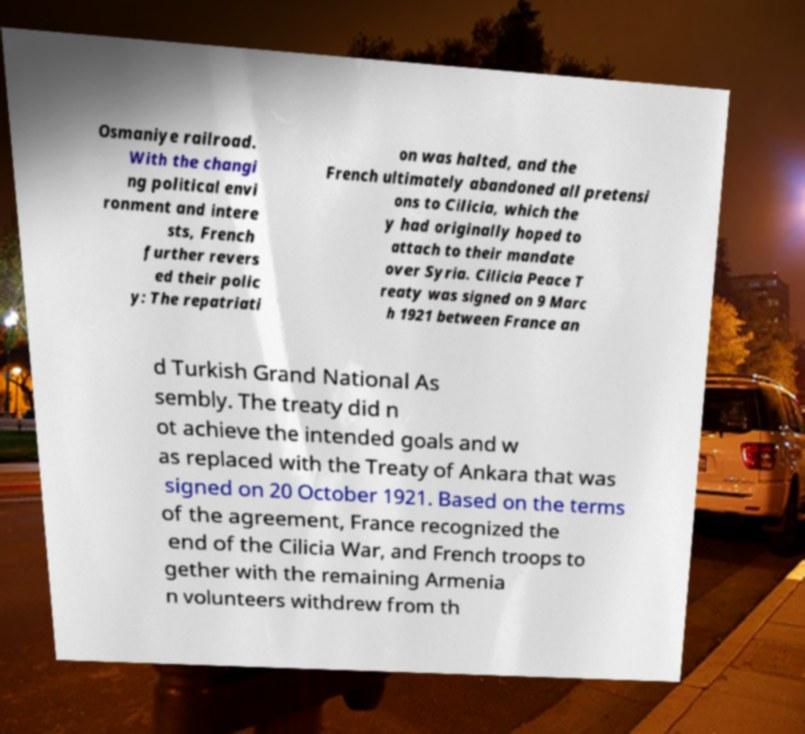Could you assist in decoding the text presented in this image and type it out clearly? Osmaniye railroad. With the changi ng political envi ronment and intere sts, French further revers ed their polic y: The repatriati on was halted, and the French ultimately abandoned all pretensi ons to Cilicia, which the y had originally hoped to attach to their mandate over Syria. Cilicia Peace T reaty was signed on 9 Marc h 1921 between France an d Turkish Grand National As sembly. The treaty did n ot achieve the intended goals and w as replaced with the Treaty of Ankara that was signed on 20 October 1921. Based on the terms of the agreement, France recognized the end of the Cilicia War, and French troops to gether with the remaining Armenia n volunteers withdrew from th 